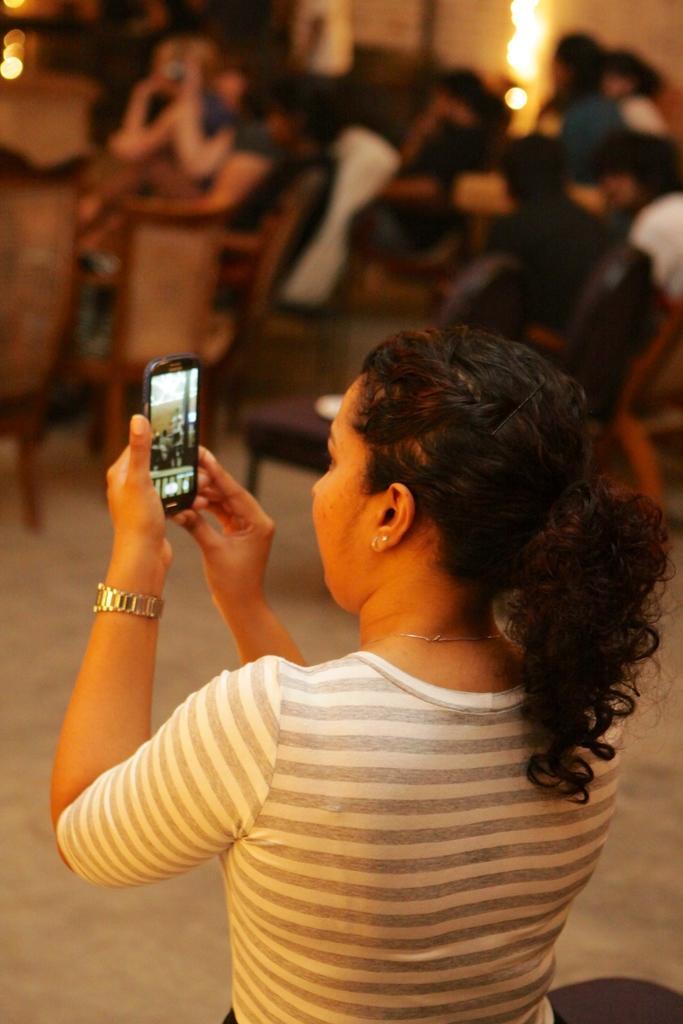Please provide a concise description of this image. This is a picture of a woman in white t shirt holding a mobile. She is wearing a watch to her left hand. In front of the woman there are group of people sitting on chairs and it is blurry. 